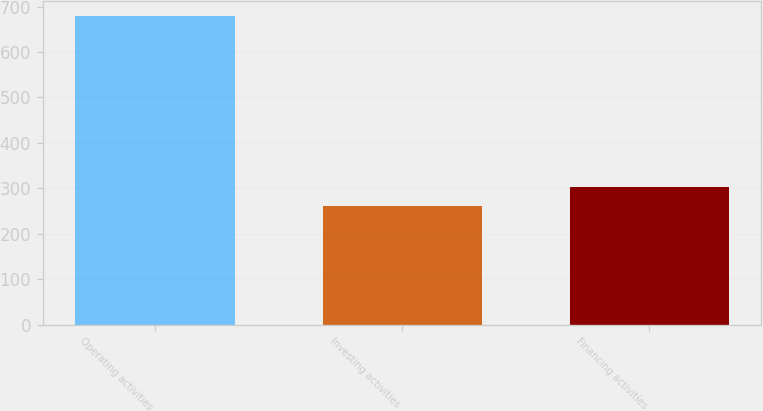Convert chart to OTSL. <chart><loc_0><loc_0><loc_500><loc_500><bar_chart><fcel>Operating activities<fcel>Investing activities<fcel>Financing activities<nl><fcel>678.3<fcel>261.9<fcel>303.54<nl></chart> 